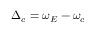Convert formula to latex. <formula><loc_0><loc_0><loc_500><loc_500>\Delta _ { c } = \omega _ { E } - \omega _ { c }</formula> 